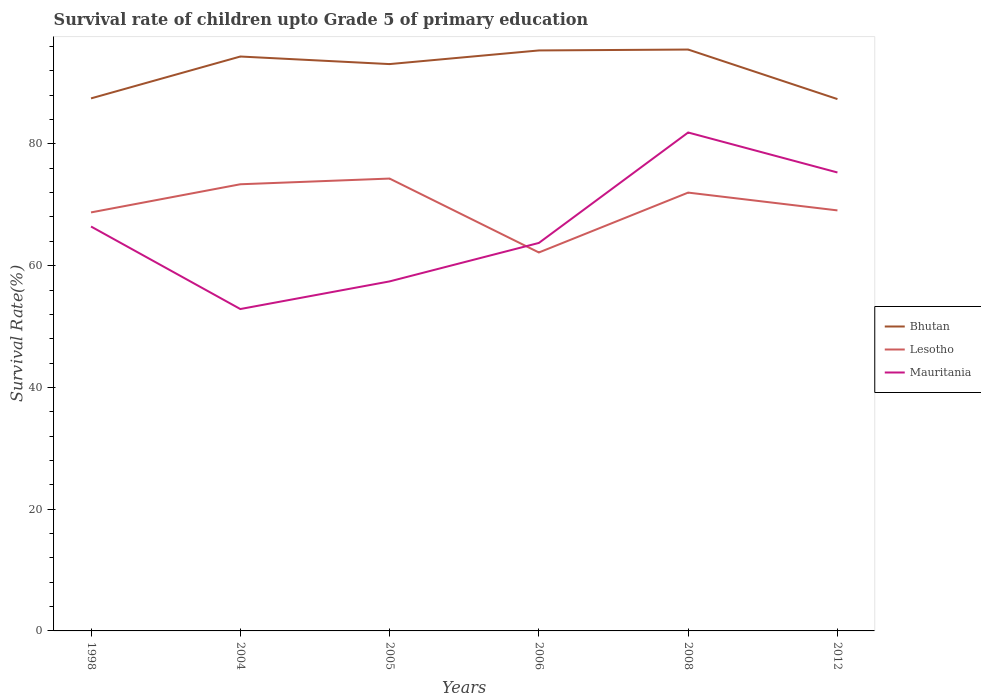Across all years, what is the maximum survival rate of children in Bhutan?
Make the answer very short. 87.37. What is the total survival rate of children in Lesotho in the graph?
Offer a terse response. 5.23. What is the difference between the highest and the second highest survival rate of children in Mauritania?
Ensure brevity in your answer.  29. Is the survival rate of children in Mauritania strictly greater than the survival rate of children in Bhutan over the years?
Keep it short and to the point. Yes. What is the difference between two consecutive major ticks on the Y-axis?
Keep it short and to the point. 20. Are the values on the major ticks of Y-axis written in scientific E-notation?
Provide a short and direct response. No. Does the graph contain any zero values?
Offer a terse response. No. Where does the legend appear in the graph?
Provide a short and direct response. Center right. How many legend labels are there?
Keep it short and to the point. 3. What is the title of the graph?
Your answer should be very brief. Survival rate of children upto Grade 5 of primary education. What is the label or title of the Y-axis?
Give a very brief answer. Survival Rate(%). What is the Survival Rate(%) in Bhutan in 1998?
Your response must be concise. 87.48. What is the Survival Rate(%) of Lesotho in 1998?
Your answer should be compact. 68.75. What is the Survival Rate(%) of Mauritania in 1998?
Provide a short and direct response. 66.43. What is the Survival Rate(%) of Bhutan in 2004?
Your answer should be very brief. 94.36. What is the Survival Rate(%) of Lesotho in 2004?
Offer a terse response. 73.37. What is the Survival Rate(%) in Mauritania in 2004?
Provide a succinct answer. 52.88. What is the Survival Rate(%) of Bhutan in 2005?
Your answer should be compact. 93.12. What is the Survival Rate(%) in Lesotho in 2005?
Provide a short and direct response. 74.31. What is the Survival Rate(%) of Mauritania in 2005?
Offer a terse response. 57.42. What is the Survival Rate(%) in Bhutan in 2006?
Make the answer very short. 95.36. What is the Survival Rate(%) in Lesotho in 2006?
Offer a terse response. 62.17. What is the Survival Rate(%) in Mauritania in 2006?
Provide a short and direct response. 63.74. What is the Survival Rate(%) of Bhutan in 2008?
Offer a terse response. 95.5. What is the Survival Rate(%) of Lesotho in 2008?
Provide a succinct answer. 72. What is the Survival Rate(%) of Mauritania in 2008?
Your answer should be compact. 81.88. What is the Survival Rate(%) in Bhutan in 2012?
Provide a succinct answer. 87.37. What is the Survival Rate(%) in Lesotho in 2012?
Make the answer very short. 69.08. What is the Survival Rate(%) of Mauritania in 2012?
Give a very brief answer. 75.31. Across all years, what is the maximum Survival Rate(%) in Bhutan?
Your response must be concise. 95.5. Across all years, what is the maximum Survival Rate(%) of Lesotho?
Give a very brief answer. 74.31. Across all years, what is the maximum Survival Rate(%) in Mauritania?
Offer a terse response. 81.88. Across all years, what is the minimum Survival Rate(%) of Bhutan?
Your answer should be compact. 87.37. Across all years, what is the minimum Survival Rate(%) in Lesotho?
Give a very brief answer. 62.17. Across all years, what is the minimum Survival Rate(%) in Mauritania?
Give a very brief answer. 52.88. What is the total Survival Rate(%) of Bhutan in the graph?
Offer a terse response. 553.19. What is the total Survival Rate(%) of Lesotho in the graph?
Provide a succinct answer. 419.69. What is the total Survival Rate(%) of Mauritania in the graph?
Provide a short and direct response. 397.65. What is the difference between the Survival Rate(%) of Bhutan in 1998 and that in 2004?
Give a very brief answer. -6.88. What is the difference between the Survival Rate(%) of Lesotho in 1998 and that in 2004?
Provide a short and direct response. -4.62. What is the difference between the Survival Rate(%) in Mauritania in 1998 and that in 2004?
Your answer should be very brief. 13.56. What is the difference between the Survival Rate(%) of Bhutan in 1998 and that in 2005?
Provide a short and direct response. -5.63. What is the difference between the Survival Rate(%) of Lesotho in 1998 and that in 2005?
Offer a terse response. -5.56. What is the difference between the Survival Rate(%) of Mauritania in 1998 and that in 2005?
Keep it short and to the point. 9.02. What is the difference between the Survival Rate(%) of Bhutan in 1998 and that in 2006?
Make the answer very short. -7.87. What is the difference between the Survival Rate(%) of Lesotho in 1998 and that in 2006?
Your answer should be compact. 6.58. What is the difference between the Survival Rate(%) in Mauritania in 1998 and that in 2006?
Provide a succinct answer. 2.7. What is the difference between the Survival Rate(%) of Bhutan in 1998 and that in 2008?
Offer a terse response. -8.02. What is the difference between the Survival Rate(%) in Lesotho in 1998 and that in 2008?
Your answer should be very brief. -3.25. What is the difference between the Survival Rate(%) in Mauritania in 1998 and that in 2008?
Offer a very short reply. -15.44. What is the difference between the Survival Rate(%) in Bhutan in 1998 and that in 2012?
Provide a short and direct response. 0.12. What is the difference between the Survival Rate(%) of Lesotho in 1998 and that in 2012?
Offer a terse response. -0.33. What is the difference between the Survival Rate(%) of Mauritania in 1998 and that in 2012?
Your answer should be very brief. -8.88. What is the difference between the Survival Rate(%) in Bhutan in 2004 and that in 2005?
Your answer should be compact. 1.24. What is the difference between the Survival Rate(%) in Lesotho in 2004 and that in 2005?
Ensure brevity in your answer.  -0.94. What is the difference between the Survival Rate(%) of Mauritania in 2004 and that in 2005?
Your answer should be very brief. -4.54. What is the difference between the Survival Rate(%) in Bhutan in 2004 and that in 2006?
Offer a very short reply. -1. What is the difference between the Survival Rate(%) of Lesotho in 2004 and that in 2006?
Offer a terse response. 11.21. What is the difference between the Survival Rate(%) of Mauritania in 2004 and that in 2006?
Provide a short and direct response. -10.86. What is the difference between the Survival Rate(%) in Bhutan in 2004 and that in 2008?
Your answer should be very brief. -1.14. What is the difference between the Survival Rate(%) in Lesotho in 2004 and that in 2008?
Offer a very short reply. 1.37. What is the difference between the Survival Rate(%) of Mauritania in 2004 and that in 2008?
Your answer should be compact. -29. What is the difference between the Survival Rate(%) in Bhutan in 2004 and that in 2012?
Offer a very short reply. 6.99. What is the difference between the Survival Rate(%) of Lesotho in 2004 and that in 2012?
Your answer should be very brief. 4.29. What is the difference between the Survival Rate(%) of Mauritania in 2004 and that in 2012?
Your response must be concise. -22.43. What is the difference between the Survival Rate(%) in Bhutan in 2005 and that in 2006?
Provide a succinct answer. -2.24. What is the difference between the Survival Rate(%) in Lesotho in 2005 and that in 2006?
Offer a terse response. 12.14. What is the difference between the Survival Rate(%) of Mauritania in 2005 and that in 2006?
Your answer should be very brief. -6.32. What is the difference between the Survival Rate(%) of Bhutan in 2005 and that in 2008?
Your response must be concise. -2.39. What is the difference between the Survival Rate(%) of Lesotho in 2005 and that in 2008?
Make the answer very short. 2.31. What is the difference between the Survival Rate(%) in Mauritania in 2005 and that in 2008?
Make the answer very short. -24.46. What is the difference between the Survival Rate(%) in Bhutan in 2005 and that in 2012?
Keep it short and to the point. 5.75. What is the difference between the Survival Rate(%) in Lesotho in 2005 and that in 2012?
Your answer should be very brief. 5.23. What is the difference between the Survival Rate(%) in Mauritania in 2005 and that in 2012?
Ensure brevity in your answer.  -17.89. What is the difference between the Survival Rate(%) in Bhutan in 2006 and that in 2008?
Offer a terse response. -0.15. What is the difference between the Survival Rate(%) in Lesotho in 2006 and that in 2008?
Your answer should be compact. -9.84. What is the difference between the Survival Rate(%) in Mauritania in 2006 and that in 2008?
Ensure brevity in your answer.  -18.14. What is the difference between the Survival Rate(%) of Bhutan in 2006 and that in 2012?
Give a very brief answer. 7.99. What is the difference between the Survival Rate(%) of Lesotho in 2006 and that in 2012?
Keep it short and to the point. -6.91. What is the difference between the Survival Rate(%) of Mauritania in 2006 and that in 2012?
Provide a short and direct response. -11.58. What is the difference between the Survival Rate(%) of Bhutan in 2008 and that in 2012?
Offer a terse response. 8.14. What is the difference between the Survival Rate(%) in Lesotho in 2008 and that in 2012?
Your answer should be very brief. 2.92. What is the difference between the Survival Rate(%) of Mauritania in 2008 and that in 2012?
Offer a terse response. 6.57. What is the difference between the Survival Rate(%) in Bhutan in 1998 and the Survival Rate(%) in Lesotho in 2004?
Ensure brevity in your answer.  14.11. What is the difference between the Survival Rate(%) in Bhutan in 1998 and the Survival Rate(%) in Mauritania in 2004?
Provide a short and direct response. 34.61. What is the difference between the Survival Rate(%) in Lesotho in 1998 and the Survival Rate(%) in Mauritania in 2004?
Provide a short and direct response. 15.87. What is the difference between the Survival Rate(%) in Bhutan in 1998 and the Survival Rate(%) in Lesotho in 2005?
Offer a terse response. 13.17. What is the difference between the Survival Rate(%) in Bhutan in 1998 and the Survival Rate(%) in Mauritania in 2005?
Offer a terse response. 30.07. What is the difference between the Survival Rate(%) of Lesotho in 1998 and the Survival Rate(%) of Mauritania in 2005?
Make the answer very short. 11.33. What is the difference between the Survival Rate(%) of Bhutan in 1998 and the Survival Rate(%) of Lesotho in 2006?
Your response must be concise. 25.32. What is the difference between the Survival Rate(%) of Bhutan in 1998 and the Survival Rate(%) of Mauritania in 2006?
Give a very brief answer. 23.75. What is the difference between the Survival Rate(%) in Lesotho in 1998 and the Survival Rate(%) in Mauritania in 2006?
Ensure brevity in your answer.  5.02. What is the difference between the Survival Rate(%) of Bhutan in 1998 and the Survival Rate(%) of Lesotho in 2008?
Provide a succinct answer. 15.48. What is the difference between the Survival Rate(%) of Bhutan in 1998 and the Survival Rate(%) of Mauritania in 2008?
Ensure brevity in your answer.  5.61. What is the difference between the Survival Rate(%) in Lesotho in 1998 and the Survival Rate(%) in Mauritania in 2008?
Provide a short and direct response. -13.13. What is the difference between the Survival Rate(%) of Bhutan in 1998 and the Survival Rate(%) of Lesotho in 2012?
Give a very brief answer. 18.4. What is the difference between the Survival Rate(%) in Bhutan in 1998 and the Survival Rate(%) in Mauritania in 2012?
Your response must be concise. 12.17. What is the difference between the Survival Rate(%) in Lesotho in 1998 and the Survival Rate(%) in Mauritania in 2012?
Make the answer very short. -6.56. What is the difference between the Survival Rate(%) in Bhutan in 2004 and the Survival Rate(%) in Lesotho in 2005?
Offer a terse response. 20.05. What is the difference between the Survival Rate(%) of Bhutan in 2004 and the Survival Rate(%) of Mauritania in 2005?
Offer a terse response. 36.94. What is the difference between the Survival Rate(%) of Lesotho in 2004 and the Survival Rate(%) of Mauritania in 2005?
Your answer should be compact. 15.96. What is the difference between the Survival Rate(%) of Bhutan in 2004 and the Survival Rate(%) of Lesotho in 2006?
Provide a succinct answer. 32.19. What is the difference between the Survival Rate(%) in Bhutan in 2004 and the Survival Rate(%) in Mauritania in 2006?
Your answer should be compact. 30.62. What is the difference between the Survival Rate(%) of Lesotho in 2004 and the Survival Rate(%) of Mauritania in 2006?
Ensure brevity in your answer.  9.64. What is the difference between the Survival Rate(%) in Bhutan in 2004 and the Survival Rate(%) in Lesotho in 2008?
Offer a terse response. 22.35. What is the difference between the Survival Rate(%) in Bhutan in 2004 and the Survival Rate(%) in Mauritania in 2008?
Offer a terse response. 12.48. What is the difference between the Survival Rate(%) of Lesotho in 2004 and the Survival Rate(%) of Mauritania in 2008?
Your answer should be very brief. -8.5. What is the difference between the Survival Rate(%) of Bhutan in 2004 and the Survival Rate(%) of Lesotho in 2012?
Make the answer very short. 25.28. What is the difference between the Survival Rate(%) in Bhutan in 2004 and the Survival Rate(%) in Mauritania in 2012?
Ensure brevity in your answer.  19.05. What is the difference between the Survival Rate(%) in Lesotho in 2004 and the Survival Rate(%) in Mauritania in 2012?
Your answer should be compact. -1.94. What is the difference between the Survival Rate(%) of Bhutan in 2005 and the Survival Rate(%) of Lesotho in 2006?
Keep it short and to the point. 30.95. What is the difference between the Survival Rate(%) of Bhutan in 2005 and the Survival Rate(%) of Mauritania in 2006?
Keep it short and to the point. 29.38. What is the difference between the Survival Rate(%) in Lesotho in 2005 and the Survival Rate(%) in Mauritania in 2006?
Give a very brief answer. 10.57. What is the difference between the Survival Rate(%) of Bhutan in 2005 and the Survival Rate(%) of Lesotho in 2008?
Ensure brevity in your answer.  21.11. What is the difference between the Survival Rate(%) of Bhutan in 2005 and the Survival Rate(%) of Mauritania in 2008?
Offer a very short reply. 11.24. What is the difference between the Survival Rate(%) of Lesotho in 2005 and the Survival Rate(%) of Mauritania in 2008?
Offer a terse response. -7.57. What is the difference between the Survival Rate(%) of Bhutan in 2005 and the Survival Rate(%) of Lesotho in 2012?
Keep it short and to the point. 24.03. What is the difference between the Survival Rate(%) in Bhutan in 2005 and the Survival Rate(%) in Mauritania in 2012?
Offer a very short reply. 17.8. What is the difference between the Survival Rate(%) of Lesotho in 2005 and the Survival Rate(%) of Mauritania in 2012?
Your answer should be very brief. -1. What is the difference between the Survival Rate(%) in Bhutan in 2006 and the Survival Rate(%) in Lesotho in 2008?
Your response must be concise. 23.35. What is the difference between the Survival Rate(%) of Bhutan in 2006 and the Survival Rate(%) of Mauritania in 2008?
Provide a succinct answer. 13.48. What is the difference between the Survival Rate(%) of Lesotho in 2006 and the Survival Rate(%) of Mauritania in 2008?
Provide a succinct answer. -19.71. What is the difference between the Survival Rate(%) of Bhutan in 2006 and the Survival Rate(%) of Lesotho in 2012?
Your answer should be compact. 26.28. What is the difference between the Survival Rate(%) in Bhutan in 2006 and the Survival Rate(%) in Mauritania in 2012?
Give a very brief answer. 20.05. What is the difference between the Survival Rate(%) in Lesotho in 2006 and the Survival Rate(%) in Mauritania in 2012?
Your response must be concise. -13.14. What is the difference between the Survival Rate(%) of Bhutan in 2008 and the Survival Rate(%) of Lesotho in 2012?
Your answer should be compact. 26.42. What is the difference between the Survival Rate(%) in Bhutan in 2008 and the Survival Rate(%) in Mauritania in 2012?
Offer a terse response. 20.19. What is the difference between the Survival Rate(%) of Lesotho in 2008 and the Survival Rate(%) of Mauritania in 2012?
Provide a succinct answer. -3.31. What is the average Survival Rate(%) in Bhutan per year?
Ensure brevity in your answer.  92.2. What is the average Survival Rate(%) in Lesotho per year?
Make the answer very short. 69.95. What is the average Survival Rate(%) in Mauritania per year?
Offer a terse response. 66.28. In the year 1998, what is the difference between the Survival Rate(%) in Bhutan and Survival Rate(%) in Lesotho?
Your answer should be very brief. 18.73. In the year 1998, what is the difference between the Survival Rate(%) in Bhutan and Survival Rate(%) in Mauritania?
Keep it short and to the point. 21.05. In the year 1998, what is the difference between the Survival Rate(%) in Lesotho and Survival Rate(%) in Mauritania?
Offer a very short reply. 2.32. In the year 2004, what is the difference between the Survival Rate(%) of Bhutan and Survival Rate(%) of Lesotho?
Your answer should be very brief. 20.99. In the year 2004, what is the difference between the Survival Rate(%) in Bhutan and Survival Rate(%) in Mauritania?
Your response must be concise. 41.48. In the year 2004, what is the difference between the Survival Rate(%) of Lesotho and Survival Rate(%) of Mauritania?
Offer a very short reply. 20.5. In the year 2005, what is the difference between the Survival Rate(%) in Bhutan and Survival Rate(%) in Lesotho?
Provide a succinct answer. 18.81. In the year 2005, what is the difference between the Survival Rate(%) in Bhutan and Survival Rate(%) in Mauritania?
Ensure brevity in your answer.  35.7. In the year 2005, what is the difference between the Survival Rate(%) of Lesotho and Survival Rate(%) of Mauritania?
Provide a succinct answer. 16.89. In the year 2006, what is the difference between the Survival Rate(%) in Bhutan and Survival Rate(%) in Lesotho?
Your answer should be compact. 33.19. In the year 2006, what is the difference between the Survival Rate(%) of Bhutan and Survival Rate(%) of Mauritania?
Your answer should be very brief. 31.62. In the year 2006, what is the difference between the Survival Rate(%) in Lesotho and Survival Rate(%) in Mauritania?
Your response must be concise. -1.57. In the year 2008, what is the difference between the Survival Rate(%) of Bhutan and Survival Rate(%) of Lesotho?
Provide a succinct answer. 23.5. In the year 2008, what is the difference between the Survival Rate(%) in Bhutan and Survival Rate(%) in Mauritania?
Make the answer very short. 13.63. In the year 2008, what is the difference between the Survival Rate(%) of Lesotho and Survival Rate(%) of Mauritania?
Offer a terse response. -9.87. In the year 2012, what is the difference between the Survival Rate(%) in Bhutan and Survival Rate(%) in Lesotho?
Make the answer very short. 18.29. In the year 2012, what is the difference between the Survival Rate(%) of Bhutan and Survival Rate(%) of Mauritania?
Offer a terse response. 12.06. In the year 2012, what is the difference between the Survival Rate(%) of Lesotho and Survival Rate(%) of Mauritania?
Provide a succinct answer. -6.23. What is the ratio of the Survival Rate(%) of Bhutan in 1998 to that in 2004?
Your answer should be compact. 0.93. What is the ratio of the Survival Rate(%) of Lesotho in 1998 to that in 2004?
Make the answer very short. 0.94. What is the ratio of the Survival Rate(%) of Mauritania in 1998 to that in 2004?
Give a very brief answer. 1.26. What is the ratio of the Survival Rate(%) of Bhutan in 1998 to that in 2005?
Give a very brief answer. 0.94. What is the ratio of the Survival Rate(%) in Lesotho in 1998 to that in 2005?
Offer a terse response. 0.93. What is the ratio of the Survival Rate(%) in Mauritania in 1998 to that in 2005?
Give a very brief answer. 1.16. What is the ratio of the Survival Rate(%) of Bhutan in 1998 to that in 2006?
Provide a succinct answer. 0.92. What is the ratio of the Survival Rate(%) in Lesotho in 1998 to that in 2006?
Provide a succinct answer. 1.11. What is the ratio of the Survival Rate(%) of Mauritania in 1998 to that in 2006?
Keep it short and to the point. 1.04. What is the ratio of the Survival Rate(%) in Bhutan in 1998 to that in 2008?
Make the answer very short. 0.92. What is the ratio of the Survival Rate(%) of Lesotho in 1998 to that in 2008?
Offer a terse response. 0.95. What is the ratio of the Survival Rate(%) in Mauritania in 1998 to that in 2008?
Offer a very short reply. 0.81. What is the ratio of the Survival Rate(%) in Mauritania in 1998 to that in 2012?
Make the answer very short. 0.88. What is the ratio of the Survival Rate(%) in Bhutan in 2004 to that in 2005?
Make the answer very short. 1.01. What is the ratio of the Survival Rate(%) of Lesotho in 2004 to that in 2005?
Offer a very short reply. 0.99. What is the ratio of the Survival Rate(%) in Mauritania in 2004 to that in 2005?
Provide a short and direct response. 0.92. What is the ratio of the Survival Rate(%) of Lesotho in 2004 to that in 2006?
Your response must be concise. 1.18. What is the ratio of the Survival Rate(%) in Mauritania in 2004 to that in 2006?
Offer a terse response. 0.83. What is the ratio of the Survival Rate(%) of Bhutan in 2004 to that in 2008?
Your answer should be compact. 0.99. What is the ratio of the Survival Rate(%) of Lesotho in 2004 to that in 2008?
Make the answer very short. 1.02. What is the ratio of the Survival Rate(%) of Mauritania in 2004 to that in 2008?
Give a very brief answer. 0.65. What is the ratio of the Survival Rate(%) in Lesotho in 2004 to that in 2012?
Your answer should be compact. 1.06. What is the ratio of the Survival Rate(%) of Mauritania in 2004 to that in 2012?
Your answer should be very brief. 0.7. What is the ratio of the Survival Rate(%) in Bhutan in 2005 to that in 2006?
Your response must be concise. 0.98. What is the ratio of the Survival Rate(%) in Lesotho in 2005 to that in 2006?
Make the answer very short. 1.2. What is the ratio of the Survival Rate(%) in Mauritania in 2005 to that in 2006?
Provide a succinct answer. 0.9. What is the ratio of the Survival Rate(%) of Lesotho in 2005 to that in 2008?
Keep it short and to the point. 1.03. What is the ratio of the Survival Rate(%) of Mauritania in 2005 to that in 2008?
Offer a terse response. 0.7. What is the ratio of the Survival Rate(%) in Bhutan in 2005 to that in 2012?
Ensure brevity in your answer.  1.07. What is the ratio of the Survival Rate(%) of Lesotho in 2005 to that in 2012?
Make the answer very short. 1.08. What is the ratio of the Survival Rate(%) in Mauritania in 2005 to that in 2012?
Provide a succinct answer. 0.76. What is the ratio of the Survival Rate(%) of Bhutan in 2006 to that in 2008?
Your answer should be compact. 1. What is the ratio of the Survival Rate(%) in Lesotho in 2006 to that in 2008?
Give a very brief answer. 0.86. What is the ratio of the Survival Rate(%) of Mauritania in 2006 to that in 2008?
Offer a terse response. 0.78. What is the ratio of the Survival Rate(%) in Bhutan in 2006 to that in 2012?
Provide a succinct answer. 1.09. What is the ratio of the Survival Rate(%) in Lesotho in 2006 to that in 2012?
Give a very brief answer. 0.9. What is the ratio of the Survival Rate(%) of Mauritania in 2006 to that in 2012?
Your answer should be compact. 0.85. What is the ratio of the Survival Rate(%) of Bhutan in 2008 to that in 2012?
Your response must be concise. 1.09. What is the ratio of the Survival Rate(%) of Lesotho in 2008 to that in 2012?
Keep it short and to the point. 1.04. What is the ratio of the Survival Rate(%) in Mauritania in 2008 to that in 2012?
Provide a short and direct response. 1.09. What is the difference between the highest and the second highest Survival Rate(%) in Bhutan?
Your answer should be very brief. 0.15. What is the difference between the highest and the second highest Survival Rate(%) in Lesotho?
Provide a short and direct response. 0.94. What is the difference between the highest and the second highest Survival Rate(%) of Mauritania?
Give a very brief answer. 6.57. What is the difference between the highest and the lowest Survival Rate(%) in Bhutan?
Ensure brevity in your answer.  8.14. What is the difference between the highest and the lowest Survival Rate(%) of Lesotho?
Ensure brevity in your answer.  12.14. What is the difference between the highest and the lowest Survival Rate(%) in Mauritania?
Make the answer very short. 29. 